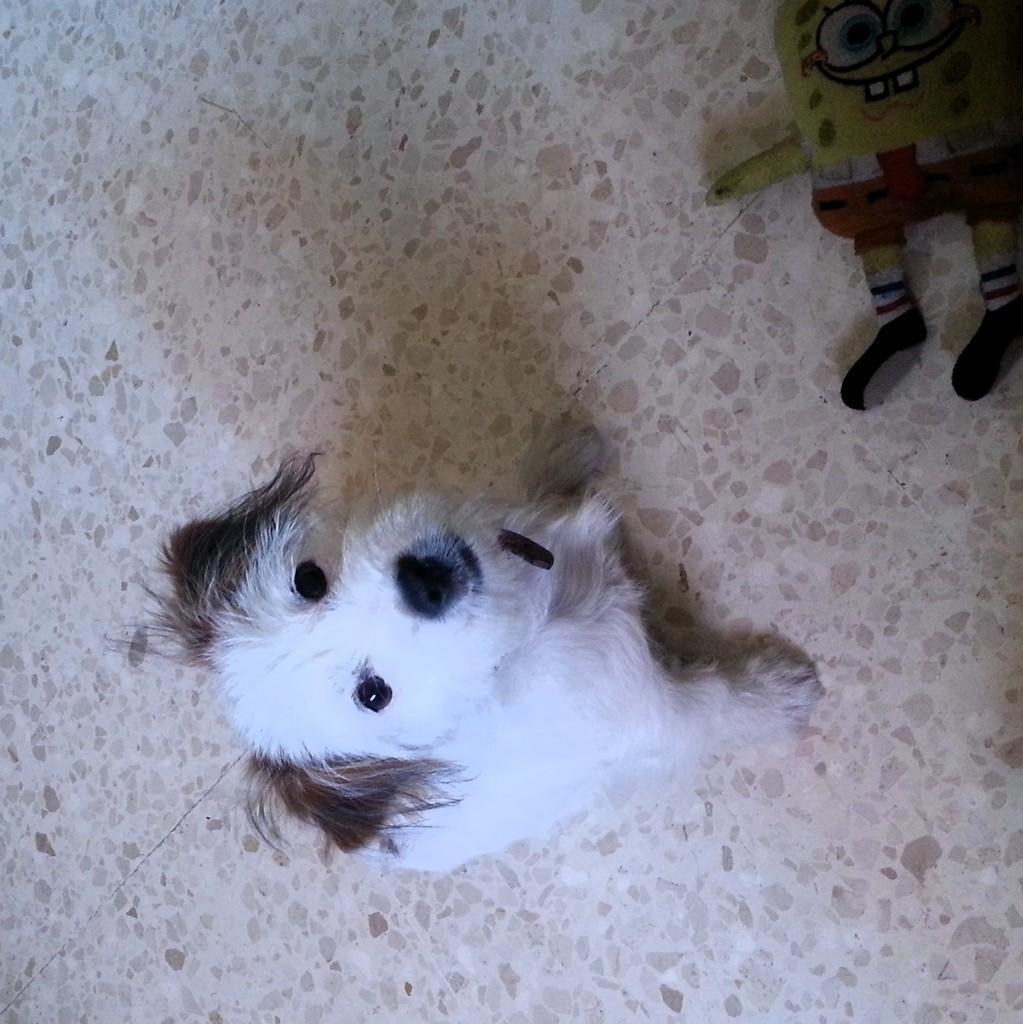In one or two sentences, can you explain what this image depicts? In the foreground of this picture we can see a white color dog. On the right corner we can see a soft toy placed on the ground. 